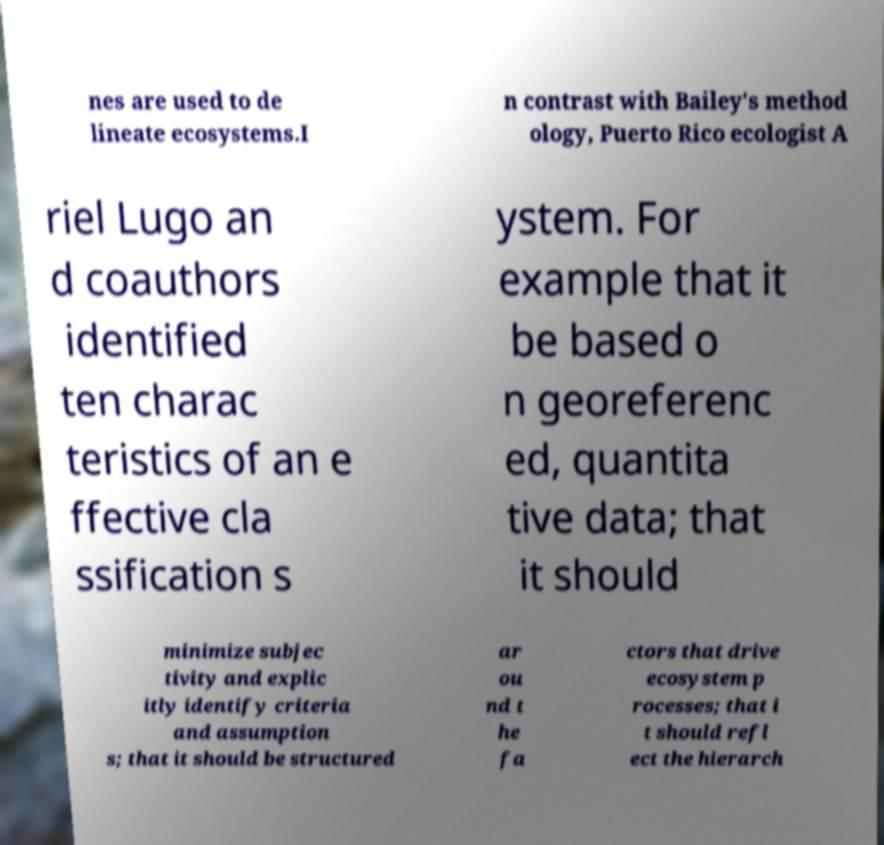What messages or text are displayed in this image? I need them in a readable, typed format. nes are used to de lineate ecosystems.I n contrast with Bailey's method ology, Puerto Rico ecologist A riel Lugo an d coauthors identified ten charac teristics of an e ffective cla ssification s ystem. For example that it be based o n georeferenc ed, quantita tive data; that it should minimize subjec tivity and explic itly identify criteria and assumption s; that it should be structured ar ou nd t he fa ctors that drive ecosystem p rocesses; that i t should refl ect the hierarch 